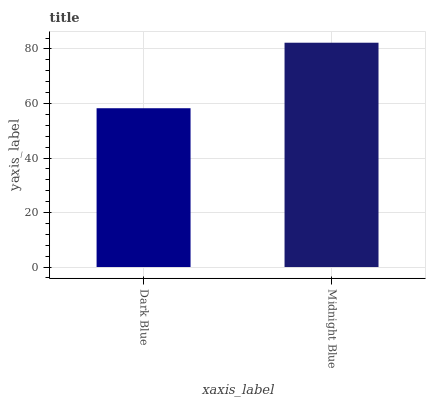Is Dark Blue the minimum?
Answer yes or no. Yes. Is Midnight Blue the maximum?
Answer yes or no. Yes. Is Midnight Blue the minimum?
Answer yes or no. No. Is Midnight Blue greater than Dark Blue?
Answer yes or no. Yes. Is Dark Blue less than Midnight Blue?
Answer yes or no. Yes. Is Dark Blue greater than Midnight Blue?
Answer yes or no. No. Is Midnight Blue less than Dark Blue?
Answer yes or no. No. Is Midnight Blue the high median?
Answer yes or no. Yes. Is Dark Blue the low median?
Answer yes or no. Yes. Is Dark Blue the high median?
Answer yes or no. No. Is Midnight Blue the low median?
Answer yes or no. No. 